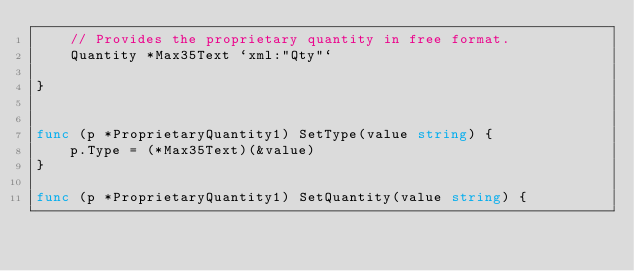<code> <loc_0><loc_0><loc_500><loc_500><_Go_>	// Provides the proprietary quantity in free format.
	Quantity *Max35Text `xml:"Qty"`

}


func (p *ProprietaryQuantity1) SetType(value string) {
	p.Type = (*Max35Text)(&value)
}

func (p *ProprietaryQuantity1) SetQuantity(value string) {</code> 